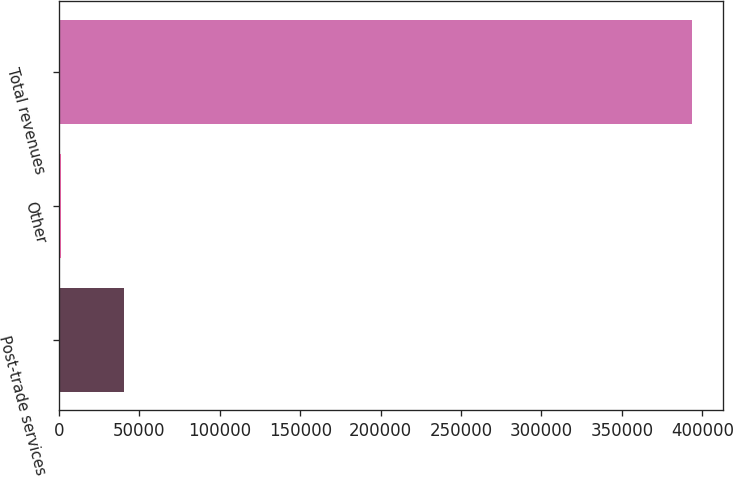Convert chart to OTSL. <chart><loc_0><loc_0><loc_500><loc_500><bar_chart><fcel>Post-trade services<fcel>Other<fcel>Total revenues<nl><fcel>40461.8<fcel>1244<fcel>393422<nl></chart> 